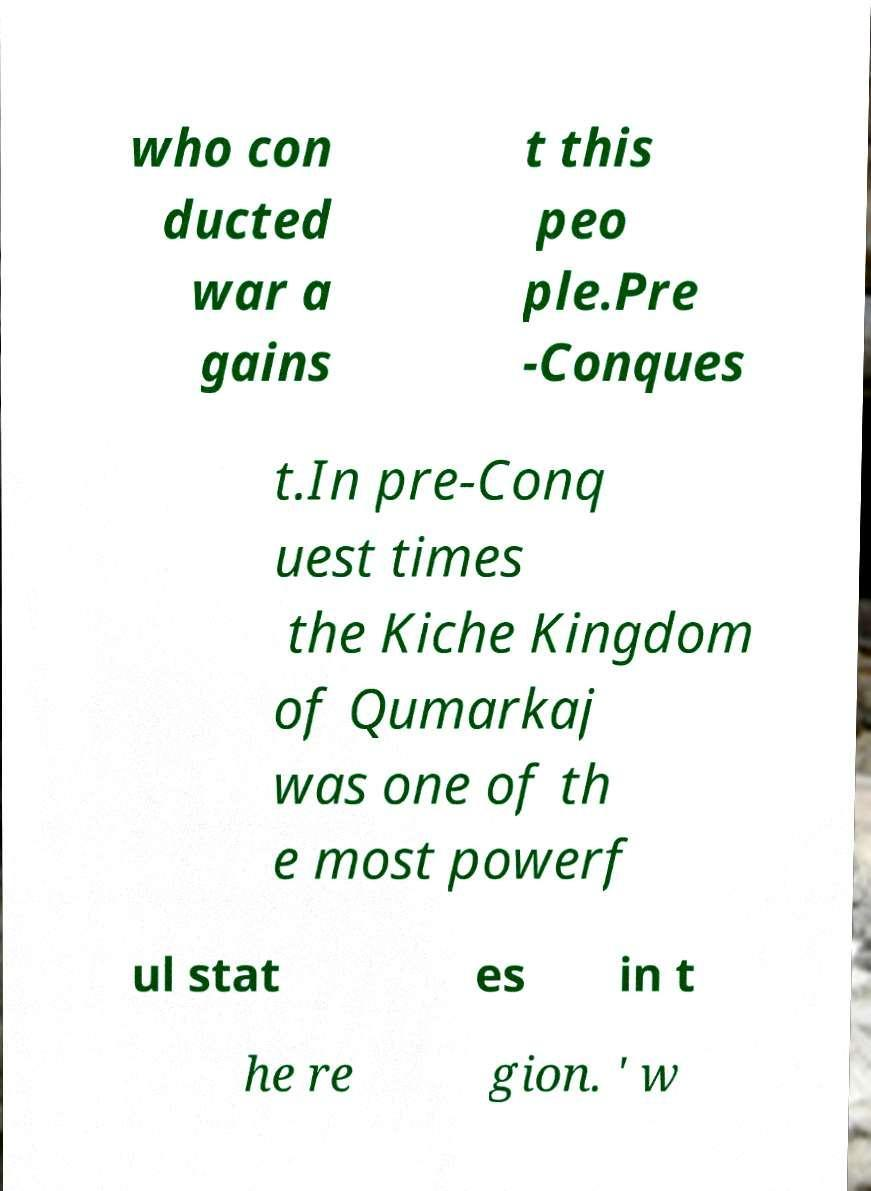Can you accurately transcribe the text from the provided image for me? who con ducted war a gains t this peo ple.Pre -Conques t.In pre-Conq uest times the Kiche Kingdom of Qumarkaj was one of th e most powerf ul stat es in t he re gion. ' w 